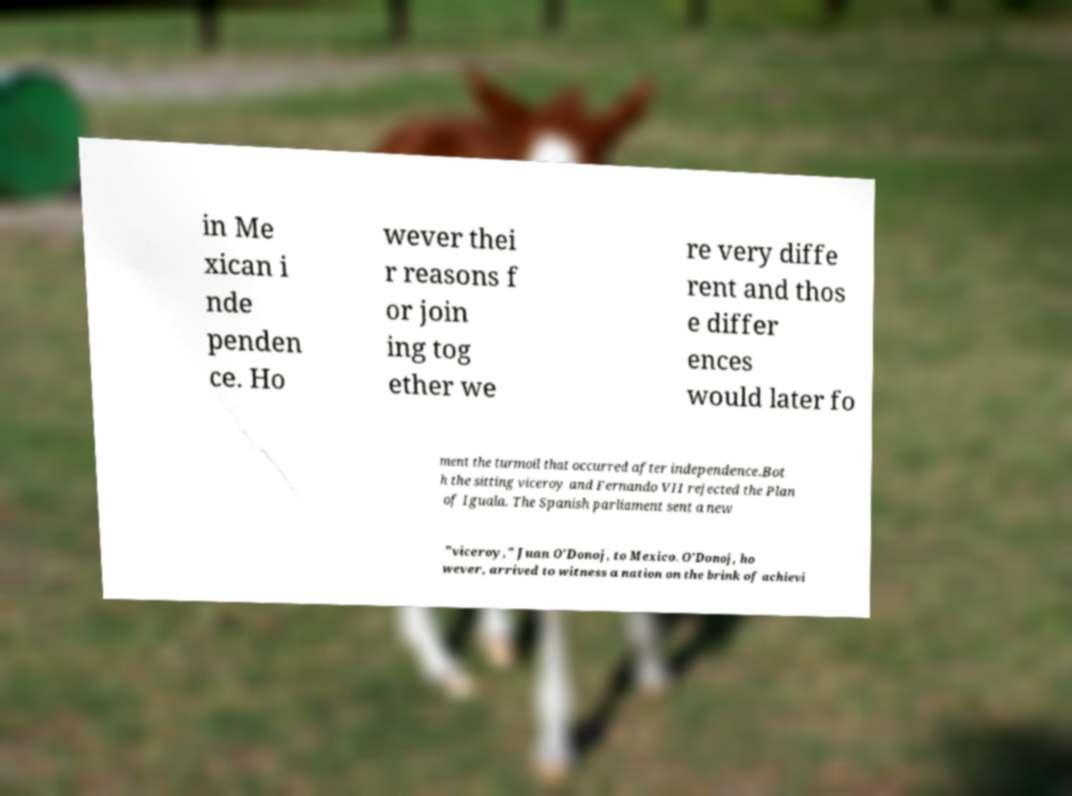For documentation purposes, I need the text within this image transcribed. Could you provide that? in Me xican i nde penden ce. Ho wever thei r reasons f or join ing tog ether we re very diffe rent and thos e differ ences would later fo ment the turmoil that occurred after independence.Bot h the sitting viceroy and Fernando VII rejected the Plan of Iguala. The Spanish parliament sent a new "viceroy," Juan O'Donoj, to Mexico. O'Donoj, ho wever, arrived to witness a nation on the brink of achievi 